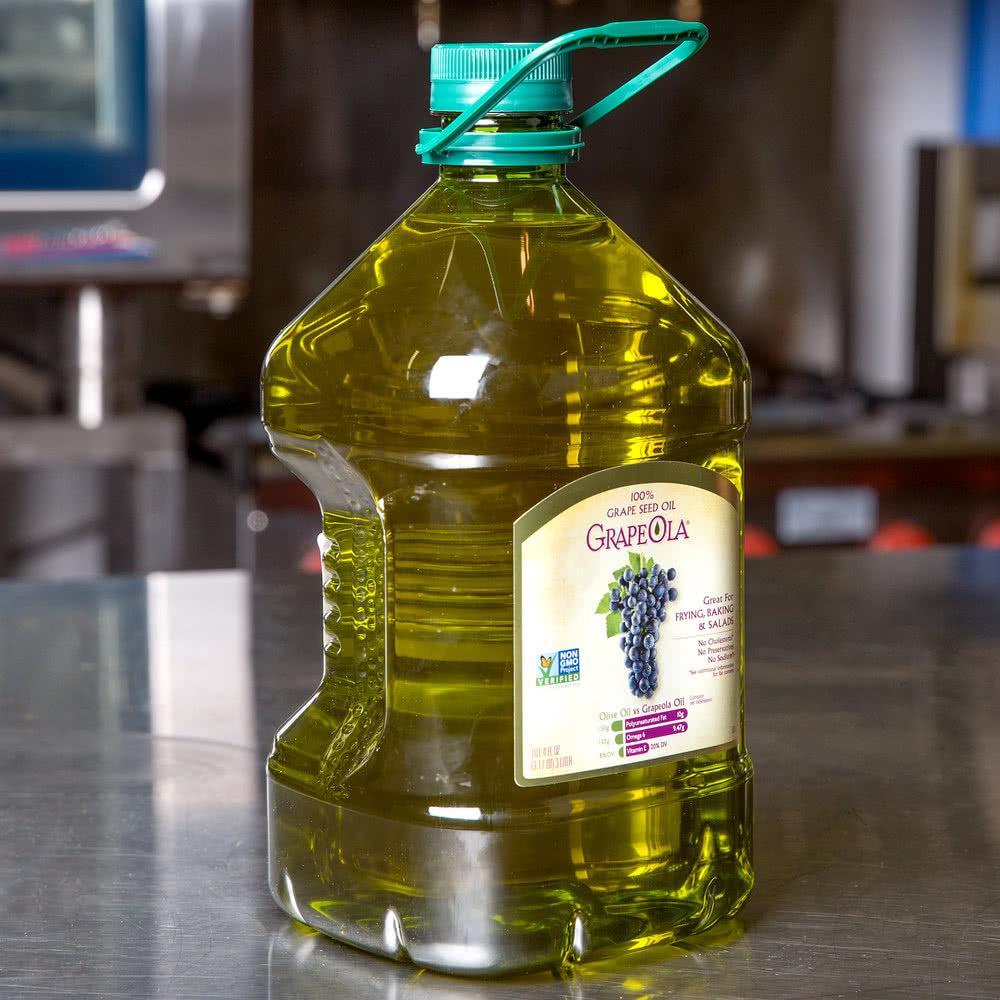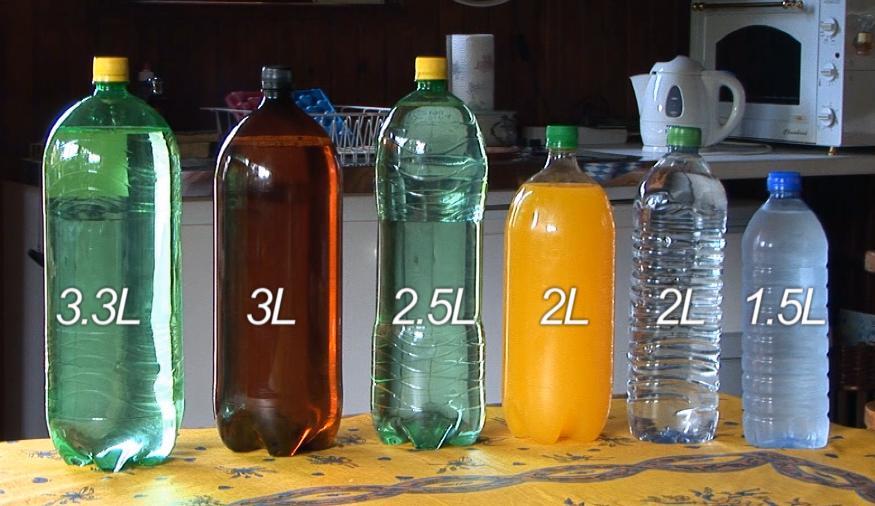The first image is the image on the left, the second image is the image on the right. For the images displayed, is the sentence "At least one image shows a stout jug with a loop-type handle." factually correct? Answer yes or no. Yes. The first image is the image on the left, the second image is the image on the right. Considering the images on both sides, is "There is at least three containers with lids on them." valid? Answer yes or no. Yes. 